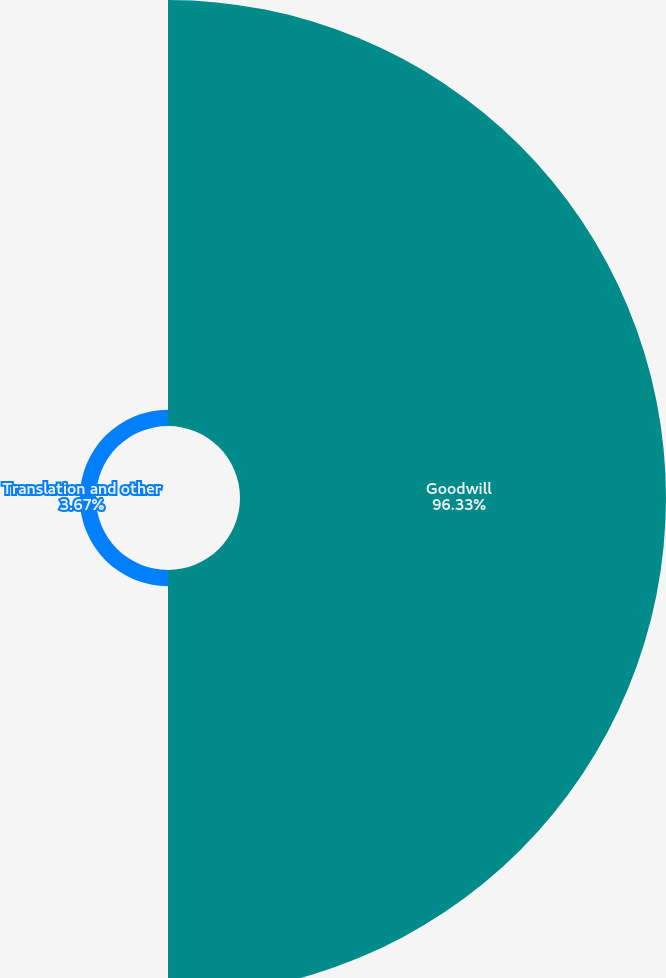Convert chart. <chart><loc_0><loc_0><loc_500><loc_500><pie_chart><fcel>Goodwill<fcel>Translation and other<nl><fcel>96.33%<fcel>3.67%<nl></chart> 